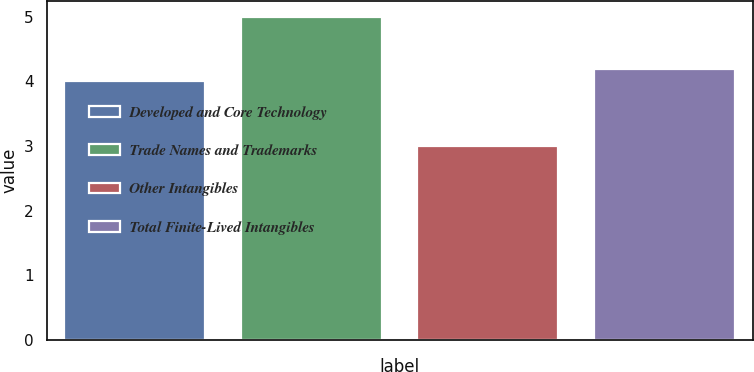Convert chart to OTSL. <chart><loc_0><loc_0><loc_500><loc_500><bar_chart><fcel>Developed and Core Technology<fcel>Trade Names and Trademarks<fcel>Other Intangibles<fcel>Total Finite-Lived Intangibles<nl><fcel>4<fcel>5<fcel>3<fcel>4.2<nl></chart> 